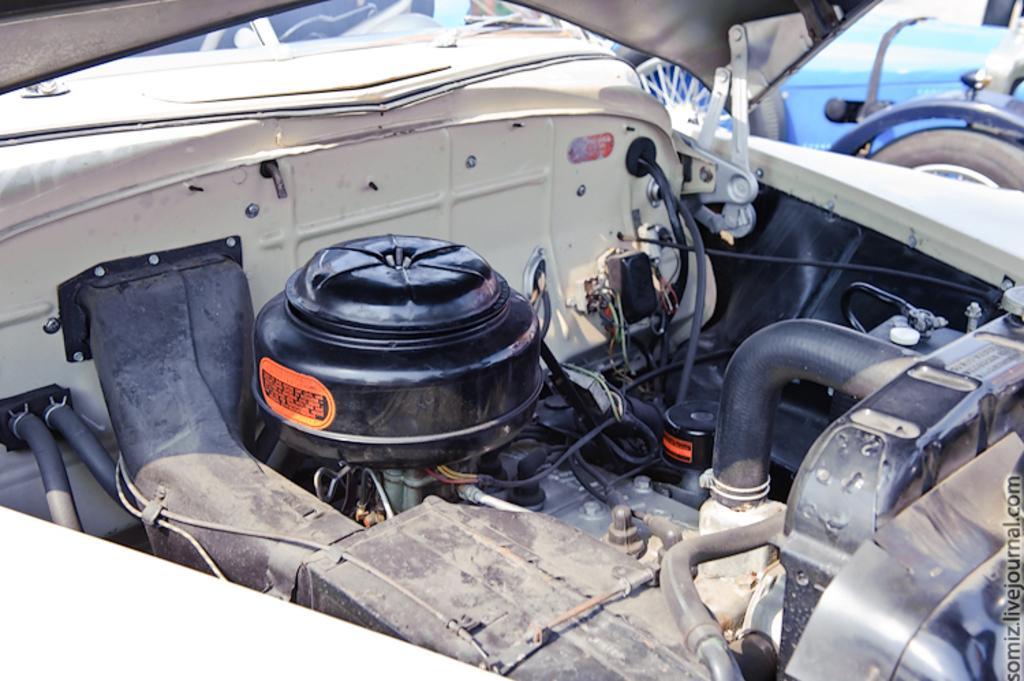Describe this image in one or two sentences. This is an inside view of a vehicle and in the background, there is an another vehicle. 